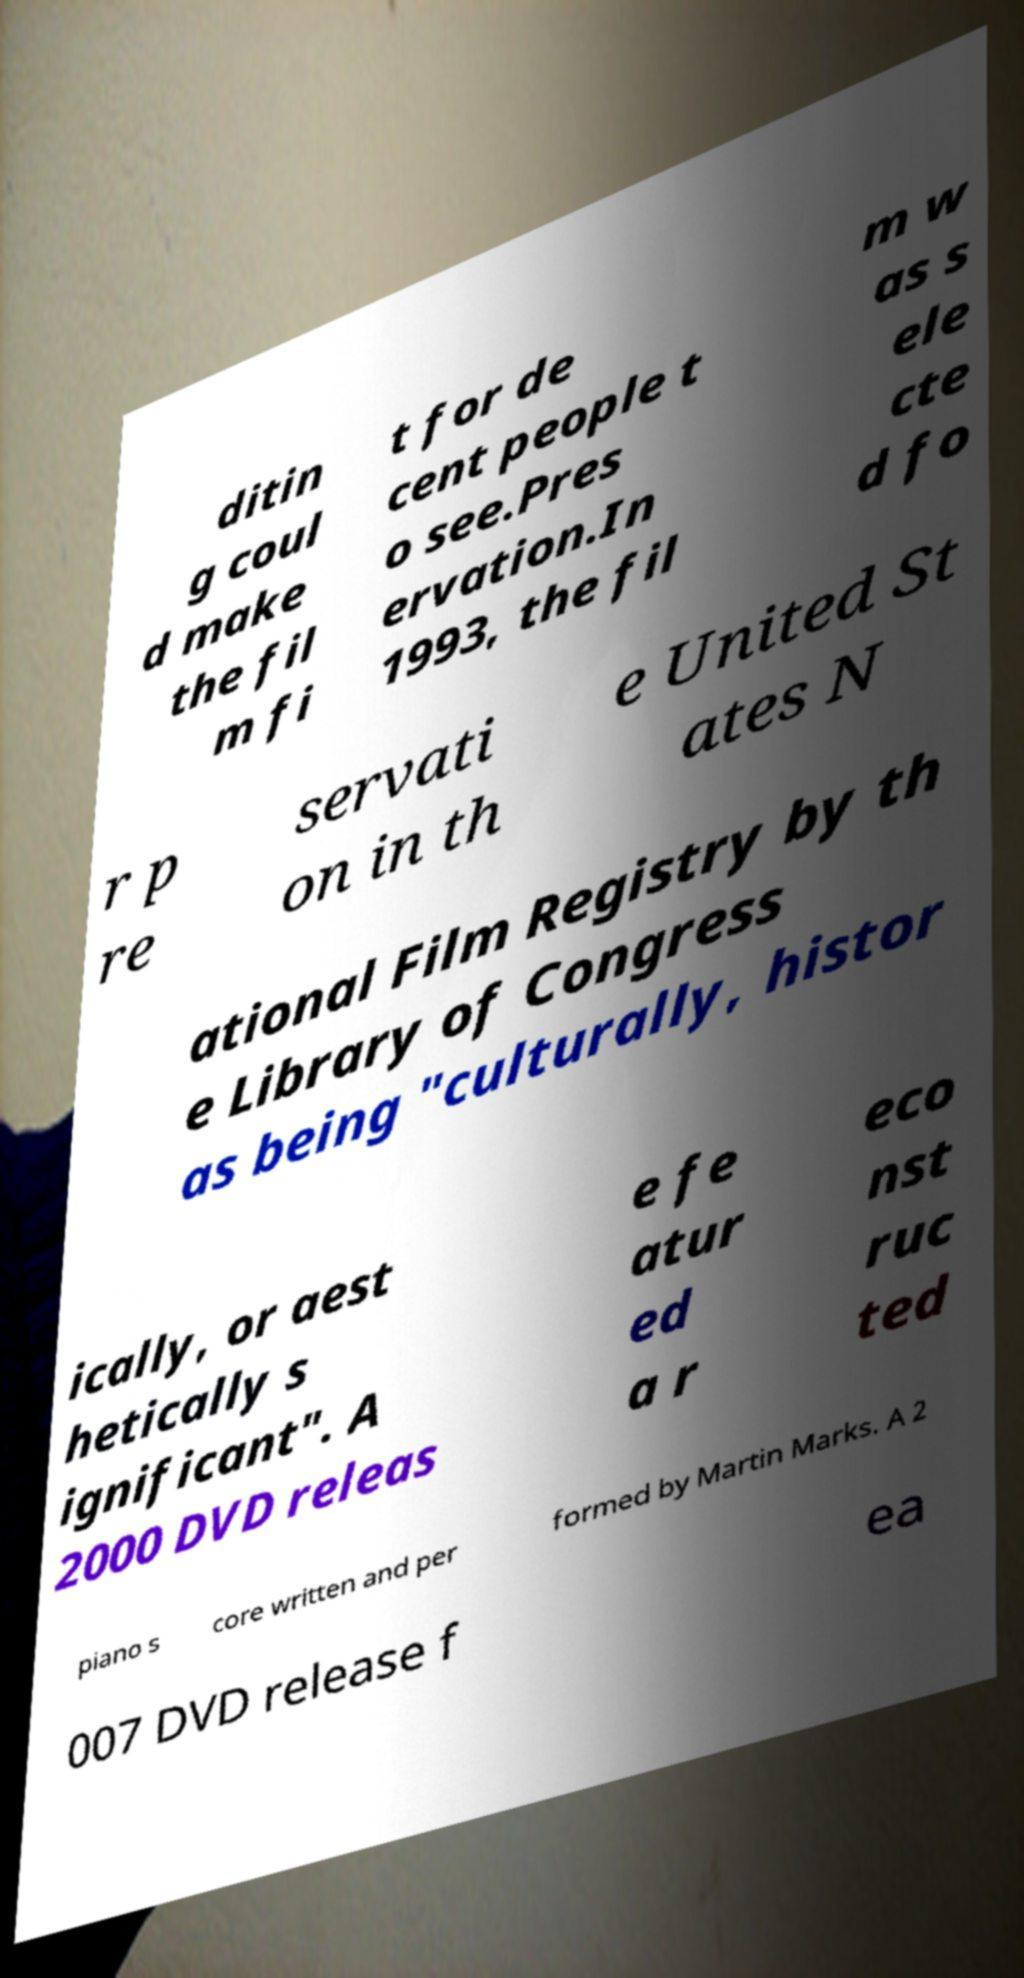Can you read and provide the text displayed in the image?This photo seems to have some interesting text. Can you extract and type it out for me? ditin g coul d make the fil m fi t for de cent people t o see.Pres ervation.In 1993, the fil m w as s ele cte d fo r p re servati on in th e United St ates N ational Film Registry by th e Library of Congress as being "culturally, histor ically, or aest hetically s ignificant". A 2000 DVD releas e fe atur ed a r eco nst ruc ted piano s core written and per formed by Martin Marks. A 2 007 DVD release f ea 